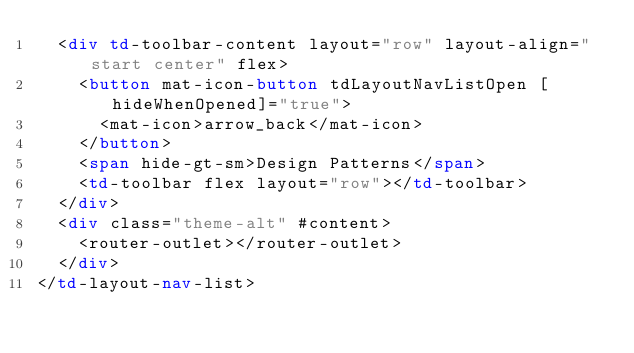Convert code to text. <code><loc_0><loc_0><loc_500><loc_500><_HTML_>  <div td-toolbar-content layout="row" layout-align="start center" flex>
    <button mat-icon-button tdLayoutNavListOpen [hideWhenOpened]="true">
      <mat-icon>arrow_back</mat-icon>
    </button>
    <span hide-gt-sm>Design Patterns</span>
    <td-toolbar flex layout="row"></td-toolbar>
  </div>
  <div class="theme-alt" #content>
    <router-outlet></router-outlet>
  </div>
</td-layout-nav-list>
</code> 